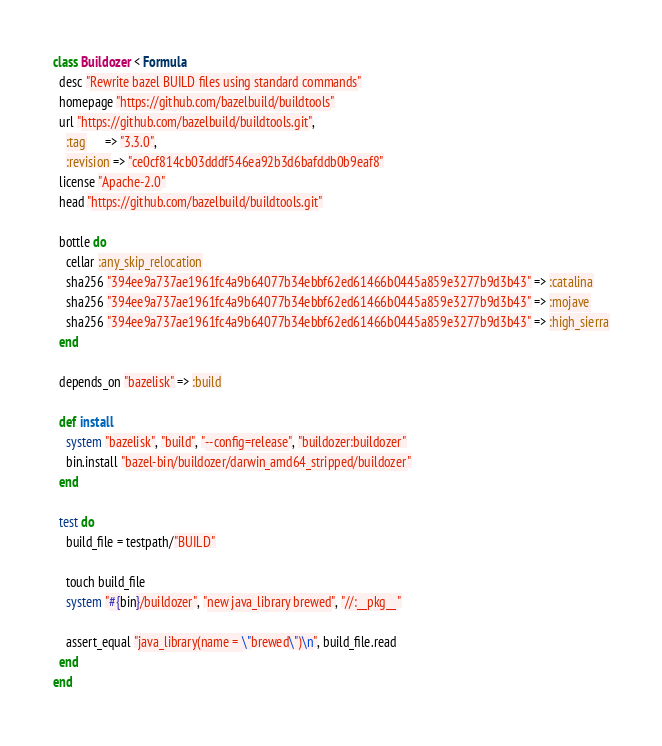Convert code to text. <code><loc_0><loc_0><loc_500><loc_500><_Ruby_>class Buildozer < Formula
  desc "Rewrite bazel BUILD files using standard commands"
  homepage "https://github.com/bazelbuild/buildtools"
  url "https://github.com/bazelbuild/buildtools.git",
    :tag      => "3.3.0",
    :revision => "ce0cf814cb03dddf546ea92b3d6bafddb0b9eaf8"
  license "Apache-2.0"
  head "https://github.com/bazelbuild/buildtools.git"

  bottle do
    cellar :any_skip_relocation
    sha256 "394ee9a737ae1961fc4a9b64077b34ebbf62ed61466b0445a859e3277b9d3b43" => :catalina
    sha256 "394ee9a737ae1961fc4a9b64077b34ebbf62ed61466b0445a859e3277b9d3b43" => :mojave
    sha256 "394ee9a737ae1961fc4a9b64077b34ebbf62ed61466b0445a859e3277b9d3b43" => :high_sierra
  end

  depends_on "bazelisk" => :build

  def install
    system "bazelisk", "build", "--config=release", "buildozer:buildozer"
    bin.install "bazel-bin/buildozer/darwin_amd64_stripped/buildozer"
  end

  test do
    build_file = testpath/"BUILD"

    touch build_file
    system "#{bin}/buildozer", "new java_library brewed", "//:__pkg__"

    assert_equal "java_library(name = \"brewed\")\n", build_file.read
  end
end
</code> 